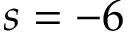Convert formula to latex. <formula><loc_0><loc_0><loc_500><loc_500>s = - 6</formula> 